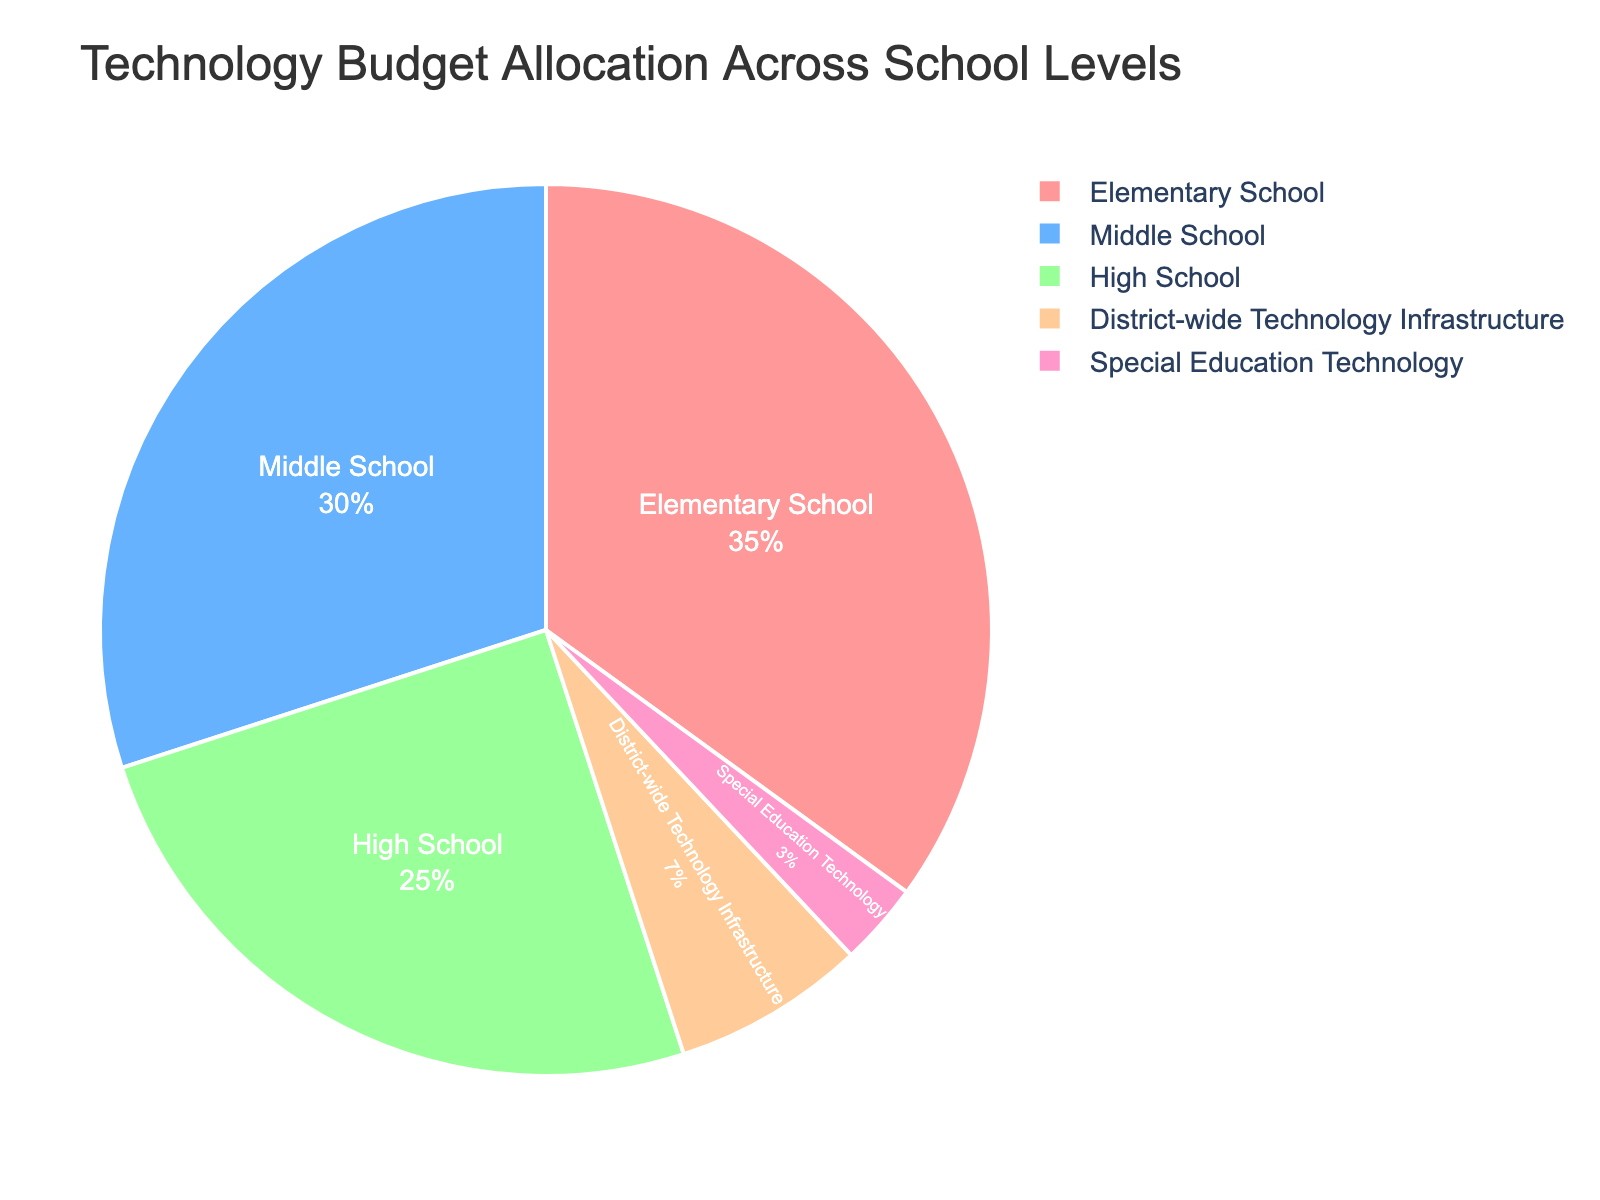Which school level receives the highest allocation of the technology budget? The pie chart shows different portions attributed to each school level, with the largest slice clearly representing the Elementary School.
Answer: Elementary School If we combine the budget allocation for Middle School and High School, what percentage of the total budget is allocated to them? The Middle School and High School each have budget allocation percentages of 30% and 25% respectively. Adding these together gives 30% + 25% = 55%.
Answer: 55% How does the budget allocation for District-wide Technology Infrastructure compare to Special Education Technology? The chart shows that District-wide Technology Infrastructure is denoted by a larger slice than Special Education Technology. The percentages are 7% and 3% respectively, indicating District-wide Technology Infrastructure has a greater allocation.
Answer: District-wide Technology Infrastructure is greater What is the difference in budget allocation between Elementary School and High School? The Elementary School has a 35% allocation while the High School has a 25% allocation. The difference is 35% - 25% = 10%.
Answer: 10% Which has the smallest portion of the technology budget? By looking at the pie chart, the smallest slice is labeled as Special Education Technology, indicating it has the smallest allocation.
Answer: Special Education Technology What percentage of the budget is allocated to areas other than Elementary, Middle, and High School combined? The allocations for areas other than these three are District-wide Technology Infrastructure (7%) and Special Education Technology (3%). Adding these gives 7% + 3% = 10%.
Answer: 10% By how much does the Elementary School budget allocation exceed that of the Middle School? The Elementary School has a 35% allocation while the Middle School has a 30% allocation. The difference is 35% - 30% = 5%.
Answer: 5% What percentage of the technology budget is dedicated strictly to school levels? Summing the percentages allocated to Elementary (35%), Middle (30%), and High School (25%) yields 35% + 30% + 25% = 90%.
Answer: 90% If the total budget is $1,000,000, how much is allocated to Middle School? The Middle School allocation is 30%. Therefore, 30% of $1,000,000 is (30/100) * $1,000,000 = $300,000.
Answer: $300,000 Compare the sum of the allocations for District-wide Technology Infrastructure and Special Education Technology to the allocation for High School. The sums for District-wide Technology Infrastructure and Special Education Technology are 7% + 3% = 10%. The High School allocation is 25%. Thus, 10% is less than 25%.
Answer: Less 